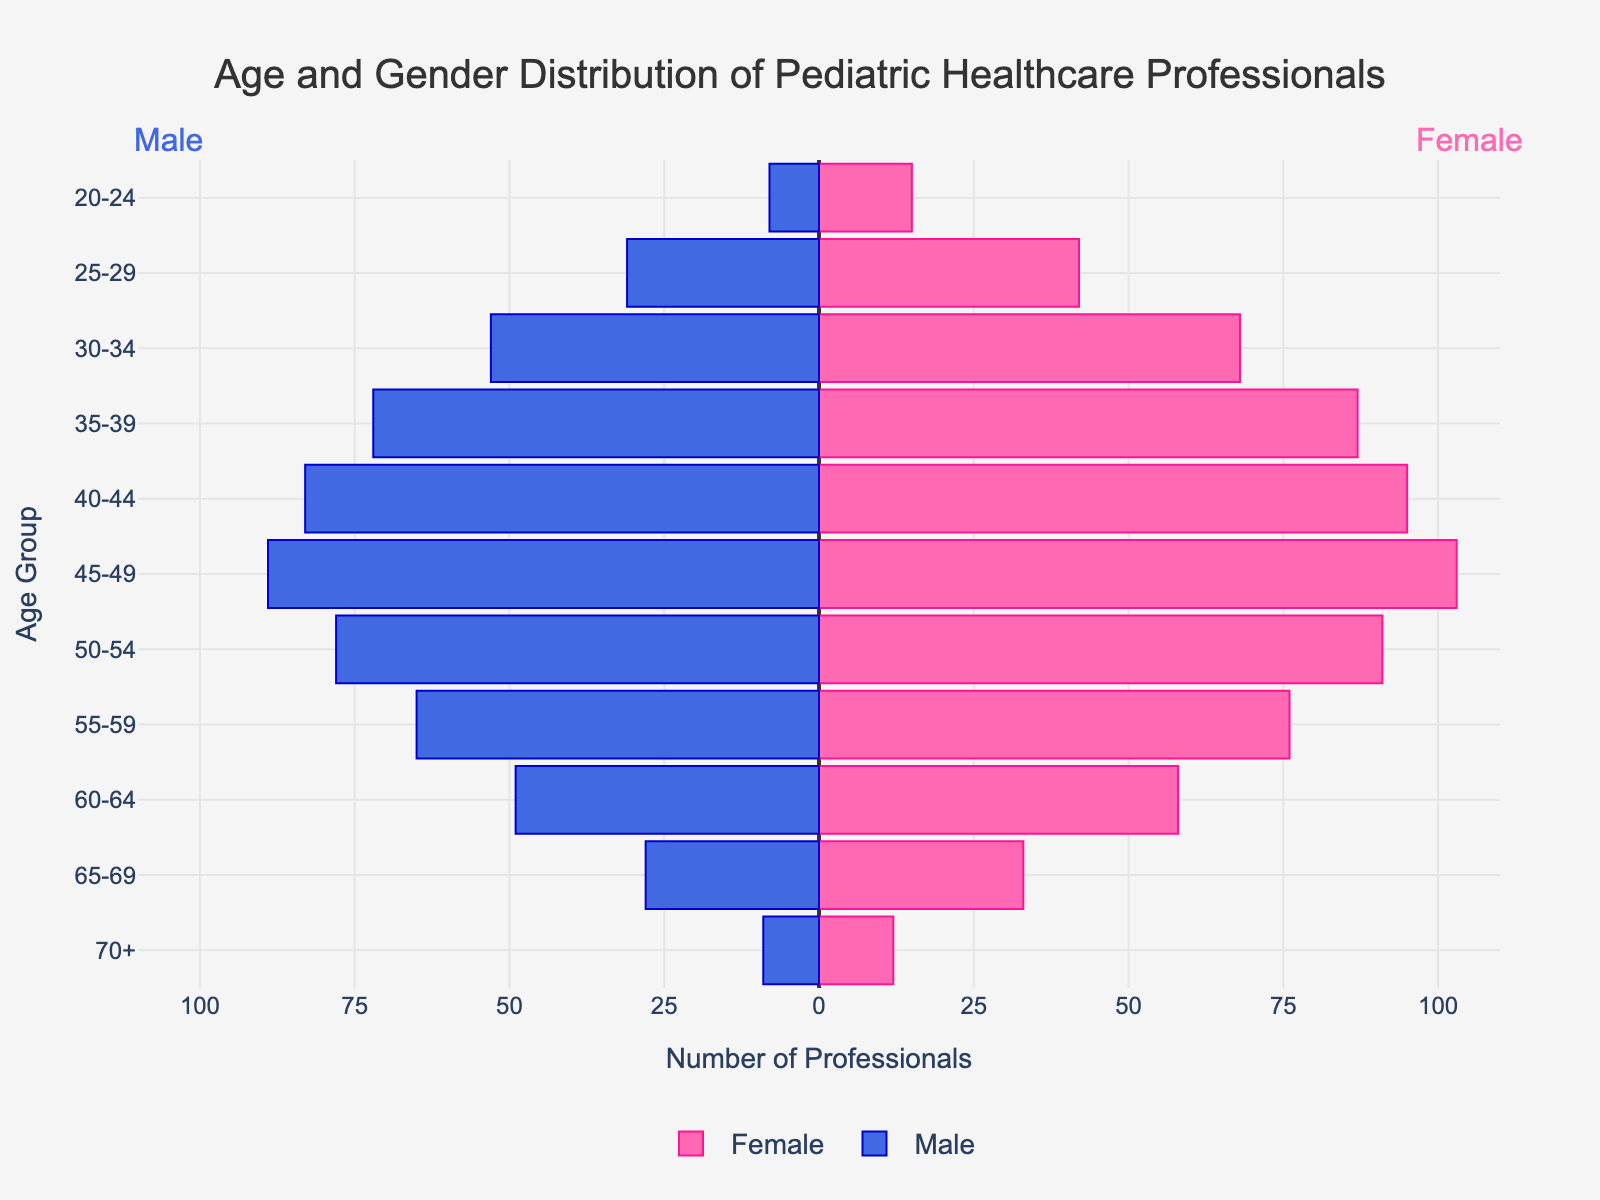What is the title of the figure? The title is displayed at the top center of the figure, indicating what the chart represents, to help viewers quickly understand the content.
Answer: Age and Gender Distribution of Pediatric Healthcare Professionals Which age group has the highest number of female pediatric healthcare professionals? Visually scan the female bars (right side of the figure) and identify the one with the highest value. The age group with the longest bar on the right side is your answer.
Answer: 45-49 How many male healthcare professionals are there in the 50-54 age group? Look at the length of the bar representing males (left side) in the 50-54 age group. Since male values are plotted as negative, note the length and convert it to a positive number.
Answer: 78 Which gender has more professionals in the 35-39 age group? Compare the lengths of the male and female bars within the 35-39 age group. The longer bar indicates the gender with more professionals.
Answer: Female What is the total number of healthcare professionals (both male and female) in the 60-64 age group? Add the number of female professionals (right side) and the number of male professionals (left side, converted to a positive).
Answer: 58 + 49 = 107 Is there any age group where the number of male and female professionals is equal? Scan through each age group and compare the lengths of the male (left) and female (right) bars. Check if any set of bars has the same length.
Answer: No Which age group has the smallest number of pediatric healthcare professionals for females and males combined? Evaluate the lengths of the bars (both male and female) for each age group and sum them, then identify the age group with the smallest total length.
Answer: 70+ What is the average number of female professionals in the age groups from 40-44 to 55-59? Add the number of female professionals in the relevant age groups and then divide by the number of those age groups. (95 + 103 + 91 + 76) / 4 = 91.25
Answer: 91.25 In which age group is the difference between the number of female and male professionals the greatest? Calculate the difference (female - male) for each age group, then identify the age group with the largest absolute difference. Differences are: 20-24: 7, 25-29: 11, 30-34: 15, 35-39: 15, 40-44: 12, 45-49: 14, 50-54: 13, 55-59: 11, 60-64: 9, 65-69: 5, 70+: 3. The greatest differences are tied between 30-34 and 35-39.
Answer: 30-34 / 35-39 Between the 20-24 and 65-69 age groups, which one has a higher combined total number of professionals? Sum the male and female professionals for both age groups separately and then compare the totals. 20-24: 15 (Female) + 8 (Male) = 23, 65-69: 33 (Female) + 28 (Male) = 61
Answer: 65-69 